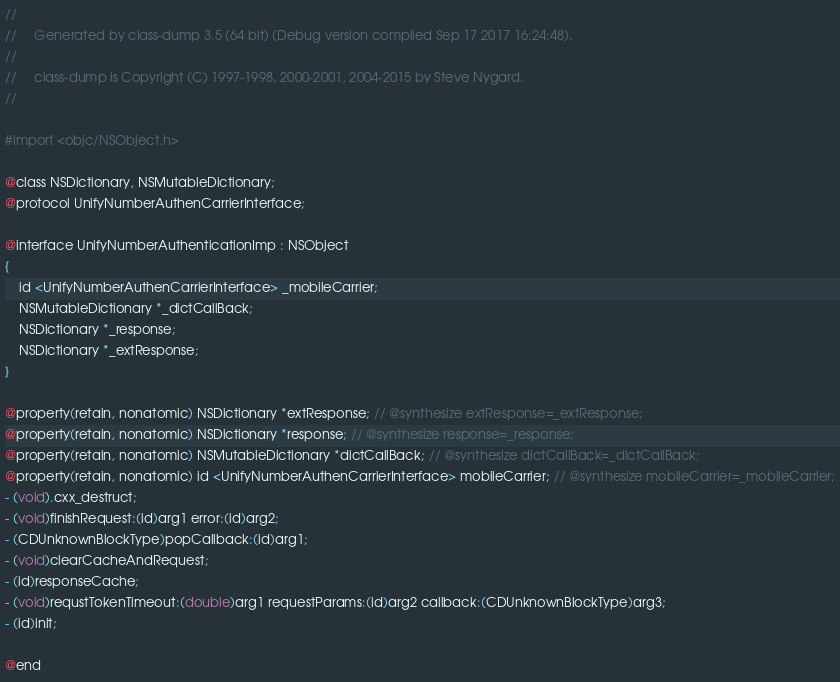Convert code to text. <code><loc_0><loc_0><loc_500><loc_500><_C_>//
//     Generated by class-dump 3.5 (64 bit) (Debug version compiled Sep 17 2017 16:24:48).
//
//     class-dump is Copyright (C) 1997-1998, 2000-2001, 2004-2015 by Steve Nygard.
//

#import <objc/NSObject.h>

@class NSDictionary, NSMutableDictionary;
@protocol UnifyNumberAuthenCarrierInterface;

@interface UnifyNumberAuthenticationImp : NSObject
{
    id <UnifyNumberAuthenCarrierInterface> _mobileCarrier;
    NSMutableDictionary *_dictCallBack;
    NSDictionary *_response;
    NSDictionary *_extResponse;
}

@property(retain, nonatomic) NSDictionary *extResponse; // @synthesize extResponse=_extResponse;
@property(retain, nonatomic) NSDictionary *response; // @synthesize response=_response;
@property(retain, nonatomic) NSMutableDictionary *dictCallBack; // @synthesize dictCallBack=_dictCallBack;
@property(retain, nonatomic) id <UnifyNumberAuthenCarrierInterface> mobileCarrier; // @synthesize mobileCarrier=_mobileCarrier;
- (void).cxx_destruct;
- (void)finishRequest:(id)arg1 error:(id)arg2;
- (CDUnknownBlockType)popCallback:(id)arg1;
- (void)clearCacheAndRequest;
- (id)responseCache;
- (void)requstTokenTimeout:(double)arg1 requestParams:(id)arg2 callback:(CDUnknownBlockType)arg3;
- (id)init;

@end

</code> 